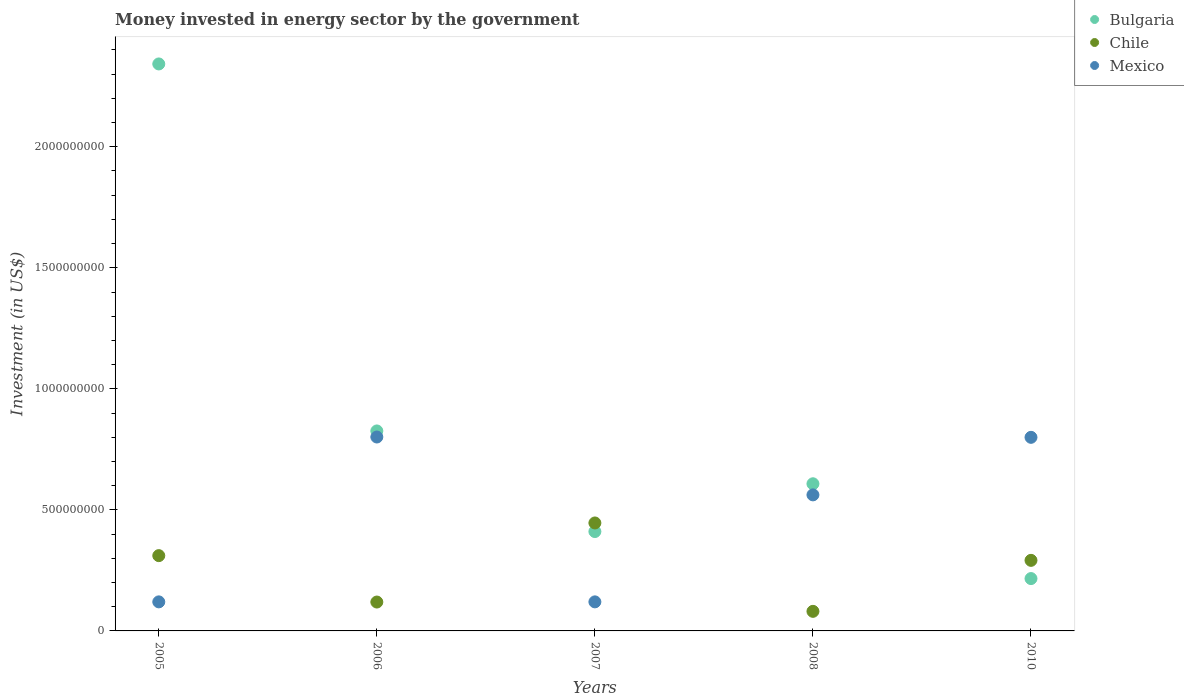Is the number of dotlines equal to the number of legend labels?
Provide a succinct answer. Yes. What is the money spent in energy sector in Mexico in 2005?
Your answer should be very brief. 1.20e+08. Across all years, what is the maximum money spent in energy sector in Bulgaria?
Offer a very short reply. 2.34e+09. Across all years, what is the minimum money spent in energy sector in Mexico?
Give a very brief answer. 1.20e+08. In which year was the money spent in energy sector in Bulgaria maximum?
Offer a very short reply. 2005. What is the total money spent in energy sector in Mexico in the graph?
Offer a very short reply. 2.40e+09. What is the difference between the money spent in energy sector in Mexico in 2005 and that in 2010?
Keep it short and to the point. -6.80e+08. What is the difference between the money spent in energy sector in Mexico in 2005 and the money spent in energy sector in Chile in 2008?
Provide a short and direct response. 3.91e+07. What is the average money spent in energy sector in Mexico per year?
Give a very brief answer. 4.81e+08. In the year 2007, what is the difference between the money spent in energy sector in Chile and money spent in energy sector in Bulgaria?
Ensure brevity in your answer.  3.55e+07. In how many years, is the money spent in energy sector in Chile greater than 1900000000 US$?
Give a very brief answer. 0. What is the ratio of the money spent in energy sector in Mexico in 2006 to that in 2007?
Provide a succinct answer. 6.67. Is the money spent in energy sector in Bulgaria in 2006 less than that in 2008?
Make the answer very short. No. What is the difference between the highest and the second highest money spent in energy sector in Bulgaria?
Provide a short and direct response. 1.52e+09. What is the difference between the highest and the lowest money spent in energy sector in Bulgaria?
Your response must be concise. 2.13e+09. Does the money spent in energy sector in Mexico monotonically increase over the years?
Make the answer very short. No. How many years are there in the graph?
Make the answer very short. 5. Does the graph contain any zero values?
Provide a short and direct response. No. Does the graph contain grids?
Make the answer very short. No. Where does the legend appear in the graph?
Keep it short and to the point. Top right. How many legend labels are there?
Ensure brevity in your answer.  3. How are the legend labels stacked?
Your answer should be very brief. Vertical. What is the title of the graph?
Give a very brief answer. Money invested in energy sector by the government. Does "Guinea-Bissau" appear as one of the legend labels in the graph?
Provide a succinct answer. No. What is the label or title of the X-axis?
Give a very brief answer. Years. What is the label or title of the Y-axis?
Your response must be concise. Investment (in US$). What is the Investment (in US$) in Bulgaria in 2005?
Give a very brief answer. 2.34e+09. What is the Investment (in US$) of Chile in 2005?
Your answer should be compact. 3.11e+08. What is the Investment (in US$) in Mexico in 2005?
Ensure brevity in your answer.  1.20e+08. What is the Investment (in US$) in Bulgaria in 2006?
Your answer should be very brief. 8.26e+08. What is the Investment (in US$) in Chile in 2006?
Offer a very short reply. 1.19e+08. What is the Investment (in US$) in Mexico in 2006?
Provide a short and direct response. 8.01e+08. What is the Investment (in US$) in Bulgaria in 2007?
Ensure brevity in your answer.  4.10e+08. What is the Investment (in US$) in Chile in 2007?
Keep it short and to the point. 4.46e+08. What is the Investment (in US$) of Mexico in 2007?
Provide a succinct answer. 1.20e+08. What is the Investment (in US$) in Bulgaria in 2008?
Your answer should be compact. 6.08e+08. What is the Investment (in US$) of Chile in 2008?
Give a very brief answer. 8.09e+07. What is the Investment (in US$) of Mexico in 2008?
Your answer should be compact. 5.62e+08. What is the Investment (in US$) in Bulgaria in 2010?
Ensure brevity in your answer.  2.16e+08. What is the Investment (in US$) of Chile in 2010?
Your answer should be very brief. 2.92e+08. What is the Investment (in US$) of Mexico in 2010?
Keep it short and to the point. 8.00e+08. Across all years, what is the maximum Investment (in US$) of Bulgaria?
Give a very brief answer. 2.34e+09. Across all years, what is the maximum Investment (in US$) of Chile?
Keep it short and to the point. 4.46e+08. Across all years, what is the maximum Investment (in US$) of Mexico?
Ensure brevity in your answer.  8.01e+08. Across all years, what is the minimum Investment (in US$) of Bulgaria?
Keep it short and to the point. 2.16e+08. Across all years, what is the minimum Investment (in US$) in Chile?
Ensure brevity in your answer.  8.09e+07. Across all years, what is the minimum Investment (in US$) in Mexico?
Provide a short and direct response. 1.20e+08. What is the total Investment (in US$) in Bulgaria in the graph?
Ensure brevity in your answer.  4.40e+09. What is the total Investment (in US$) of Chile in the graph?
Keep it short and to the point. 1.25e+09. What is the total Investment (in US$) of Mexico in the graph?
Give a very brief answer. 2.40e+09. What is the difference between the Investment (in US$) of Bulgaria in 2005 and that in 2006?
Keep it short and to the point. 1.52e+09. What is the difference between the Investment (in US$) in Chile in 2005 and that in 2006?
Provide a succinct answer. 1.92e+08. What is the difference between the Investment (in US$) in Mexico in 2005 and that in 2006?
Keep it short and to the point. -6.81e+08. What is the difference between the Investment (in US$) of Bulgaria in 2005 and that in 2007?
Your response must be concise. 1.93e+09. What is the difference between the Investment (in US$) of Chile in 2005 and that in 2007?
Offer a terse response. -1.35e+08. What is the difference between the Investment (in US$) of Bulgaria in 2005 and that in 2008?
Give a very brief answer. 1.73e+09. What is the difference between the Investment (in US$) in Chile in 2005 and that in 2008?
Ensure brevity in your answer.  2.30e+08. What is the difference between the Investment (in US$) of Mexico in 2005 and that in 2008?
Offer a terse response. -4.42e+08. What is the difference between the Investment (in US$) in Bulgaria in 2005 and that in 2010?
Make the answer very short. 2.13e+09. What is the difference between the Investment (in US$) of Chile in 2005 and that in 2010?
Provide a short and direct response. 1.95e+07. What is the difference between the Investment (in US$) of Mexico in 2005 and that in 2010?
Give a very brief answer. -6.80e+08. What is the difference between the Investment (in US$) in Bulgaria in 2006 and that in 2007?
Offer a terse response. 4.16e+08. What is the difference between the Investment (in US$) in Chile in 2006 and that in 2007?
Make the answer very short. -3.27e+08. What is the difference between the Investment (in US$) in Mexico in 2006 and that in 2007?
Provide a short and direct response. 6.81e+08. What is the difference between the Investment (in US$) of Bulgaria in 2006 and that in 2008?
Your answer should be compact. 2.18e+08. What is the difference between the Investment (in US$) of Chile in 2006 and that in 2008?
Give a very brief answer. 3.84e+07. What is the difference between the Investment (in US$) in Mexico in 2006 and that in 2008?
Provide a short and direct response. 2.39e+08. What is the difference between the Investment (in US$) of Bulgaria in 2006 and that in 2010?
Provide a succinct answer. 6.10e+08. What is the difference between the Investment (in US$) in Chile in 2006 and that in 2010?
Make the answer very short. -1.72e+08. What is the difference between the Investment (in US$) in Mexico in 2006 and that in 2010?
Provide a short and direct response. 1.30e+06. What is the difference between the Investment (in US$) of Bulgaria in 2007 and that in 2008?
Your answer should be very brief. -1.97e+08. What is the difference between the Investment (in US$) of Chile in 2007 and that in 2008?
Offer a very short reply. 3.65e+08. What is the difference between the Investment (in US$) in Mexico in 2007 and that in 2008?
Provide a succinct answer. -4.42e+08. What is the difference between the Investment (in US$) in Bulgaria in 2007 and that in 2010?
Offer a terse response. 1.94e+08. What is the difference between the Investment (in US$) in Chile in 2007 and that in 2010?
Ensure brevity in your answer.  1.54e+08. What is the difference between the Investment (in US$) in Mexico in 2007 and that in 2010?
Your answer should be very brief. -6.80e+08. What is the difference between the Investment (in US$) of Bulgaria in 2008 and that in 2010?
Provide a short and direct response. 3.92e+08. What is the difference between the Investment (in US$) in Chile in 2008 and that in 2010?
Make the answer very short. -2.11e+08. What is the difference between the Investment (in US$) in Mexico in 2008 and that in 2010?
Give a very brief answer. -2.38e+08. What is the difference between the Investment (in US$) of Bulgaria in 2005 and the Investment (in US$) of Chile in 2006?
Provide a short and direct response. 2.22e+09. What is the difference between the Investment (in US$) of Bulgaria in 2005 and the Investment (in US$) of Mexico in 2006?
Give a very brief answer. 1.54e+09. What is the difference between the Investment (in US$) of Chile in 2005 and the Investment (in US$) of Mexico in 2006?
Offer a very short reply. -4.90e+08. What is the difference between the Investment (in US$) of Bulgaria in 2005 and the Investment (in US$) of Chile in 2007?
Ensure brevity in your answer.  1.90e+09. What is the difference between the Investment (in US$) of Bulgaria in 2005 and the Investment (in US$) of Mexico in 2007?
Keep it short and to the point. 2.22e+09. What is the difference between the Investment (in US$) of Chile in 2005 and the Investment (in US$) of Mexico in 2007?
Your answer should be compact. 1.91e+08. What is the difference between the Investment (in US$) of Bulgaria in 2005 and the Investment (in US$) of Chile in 2008?
Make the answer very short. 2.26e+09. What is the difference between the Investment (in US$) in Bulgaria in 2005 and the Investment (in US$) in Mexico in 2008?
Make the answer very short. 1.78e+09. What is the difference between the Investment (in US$) in Chile in 2005 and the Investment (in US$) in Mexico in 2008?
Keep it short and to the point. -2.51e+08. What is the difference between the Investment (in US$) of Bulgaria in 2005 and the Investment (in US$) of Chile in 2010?
Give a very brief answer. 2.05e+09. What is the difference between the Investment (in US$) of Bulgaria in 2005 and the Investment (in US$) of Mexico in 2010?
Keep it short and to the point. 1.54e+09. What is the difference between the Investment (in US$) in Chile in 2005 and the Investment (in US$) in Mexico in 2010?
Your answer should be very brief. -4.89e+08. What is the difference between the Investment (in US$) in Bulgaria in 2006 and the Investment (in US$) in Chile in 2007?
Offer a very short reply. 3.80e+08. What is the difference between the Investment (in US$) of Bulgaria in 2006 and the Investment (in US$) of Mexico in 2007?
Your answer should be compact. 7.06e+08. What is the difference between the Investment (in US$) in Chile in 2006 and the Investment (in US$) in Mexico in 2007?
Ensure brevity in your answer.  -7.00e+05. What is the difference between the Investment (in US$) in Bulgaria in 2006 and the Investment (in US$) in Chile in 2008?
Provide a short and direct response. 7.45e+08. What is the difference between the Investment (in US$) in Bulgaria in 2006 and the Investment (in US$) in Mexico in 2008?
Your answer should be very brief. 2.64e+08. What is the difference between the Investment (in US$) of Chile in 2006 and the Investment (in US$) of Mexico in 2008?
Offer a very short reply. -4.43e+08. What is the difference between the Investment (in US$) of Bulgaria in 2006 and the Investment (in US$) of Chile in 2010?
Offer a very short reply. 5.35e+08. What is the difference between the Investment (in US$) of Bulgaria in 2006 and the Investment (in US$) of Mexico in 2010?
Keep it short and to the point. 2.64e+07. What is the difference between the Investment (in US$) of Chile in 2006 and the Investment (in US$) of Mexico in 2010?
Offer a very short reply. -6.80e+08. What is the difference between the Investment (in US$) in Bulgaria in 2007 and the Investment (in US$) in Chile in 2008?
Provide a short and direct response. 3.30e+08. What is the difference between the Investment (in US$) in Bulgaria in 2007 and the Investment (in US$) in Mexico in 2008?
Ensure brevity in your answer.  -1.52e+08. What is the difference between the Investment (in US$) of Chile in 2007 and the Investment (in US$) of Mexico in 2008?
Offer a very short reply. -1.16e+08. What is the difference between the Investment (in US$) in Bulgaria in 2007 and the Investment (in US$) in Chile in 2010?
Provide a succinct answer. 1.19e+08. What is the difference between the Investment (in US$) in Bulgaria in 2007 and the Investment (in US$) in Mexico in 2010?
Keep it short and to the point. -3.89e+08. What is the difference between the Investment (in US$) in Chile in 2007 and the Investment (in US$) in Mexico in 2010?
Provide a succinct answer. -3.54e+08. What is the difference between the Investment (in US$) of Bulgaria in 2008 and the Investment (in US$) of Chile in 2010?
Offer a terse response. 3.16e+08. What is the difference between the Investment (in US$) in Bulgaria in 2008 and the Investment (in US$) in Mexico in 2010?
Keep it short and to the point. -1.92e+08. What is the difference between the Investment (in US$) of Chile in 2008 and the Investment (in US$) of Mexico in 2010?
Ensure brevity in your answer.  -7.19e+08. What is the average Investment (in US$) in Bulgaria per year?
Provide a short and direct response. 8.81e+08. What is the average Investment (in US$) of Chile per year?
Make the answer very short. 2.50e+08. What is the average Investment (in US$) of Mexico per year?
Provide a succinct answer. 4.81e+08. In the year 2005, what is the difference between the Investment (in US$) in Bulgaria and Investment (in US$) in Chile?
Offer a terse response. 2.03e+09. In the year 2005, what is the difference between the Investment (in US$) in Bulgaria and Investment (in US$) in Mexico?
Provide a succinct answer. 2.22e+09. In the year 2005, what is the difference between the Investment (in US$) of Chile and Investment (in US$) of Mexico?
Provide a succinct answer. 1.91e+08. In the year 2006, what is the difference between the Investment (in US$) of Bulgaria and Investment (in US$) of Chile?
Your answer should be very brief. 7.07e+08. In the year 2006, what is the difference between the Investment (in US$) in Bulgaria and Investment (in US$) in Mexico?
Offer a very short reply. 2.51e+07. In the year 2006, what is the difference between the Investment (in US$) in Chile and Investment (in US$) in Mexico?
Your response must be concise. -6.82e+08. In the year 2007, what is the difference between the Investment (in US$) in Bulgaria and Investment (in US$) in Chile?
Keep it short and to the point. -3.55e+07. In the year 2007, what is the difference between the Investment (in US$) of Bulgaria and Investment (in US$) of Mexico?
Make the answer very short. 2.90e+08. In the year 2007, what is the difference between the Investment (in US$) of Chile and Investment (in US$) of Mexico?
Offer a terse response. 3.26e+08. In the year 2008, what is the difference between the Investment (in US$) in Bulgaria and Investment (in US$) in Chile?
Provide a succinct answer. 5.27e+08. In the year 2008, what is the difference between the Investment (in US$) in Bulgaria and Investment (in US$) in Mexico?
Ensure brevity in your answer.  4.59e+07. In the year 2008, what is the difference between the Investment (in US$) in Chile and Investment (in US$) in Mexico?
Your answer should be very brief. -4.81e+08. In the year 2010, what is the difference between the Investment (in US$) in Bulgaria and Investment (in US$) in Chile?
Your answer should be compact. -7.53e+07. In the year 2010, what is the difference between the Investment (in US$) of Bulgaria and Investment (in US$) of Mexico?
Offer a terse response. -5.83e+08. In the year 2010, what is the difference between the Investment (in US$) in Chile and Investment (in US$) in Mexico?
Your response must be concise. -5.08e+08. What is the ratio of the Investment (in US$) of Bulgaria in 2005 to that in 2006?
Your response must be concise. 2.84. What is the ratio of the Investment (in US$) of Chile in 2005 to that in 2006?
Give a very brief answer. 2.61. What is the ratio of the Investment (in US$) of Mexico in 2005 to that in 2006?
Keep it short and to the point. 0.15. What is the ratio of the Investment (in US$) in Bulgaria in 2005 to that in 2007?
Ensure brevity in your answer.  5.71. What is the ratio of the Investment (in US$) in Chile in 2005 to that in 2007?
Offer a very short reply. 0.7. What is the ratio of the Investment (in US$) of Bulgaria in 2005 to that in 2008?
Offer a very short reply. 3.85. What is the ratio of the Investment (in US$) of Chile in 2005 to that in 2008?
Your answer should be compact. 3.85. What is the ratio of the Investment (in US$) of Mexico in 2005 to that in 2008?
Your answer should be compact. 0.21. What is the ratio of the Investment (in US$) of Bulgaria in 2005 to that in 2010?
Give a very brief answer. 10.83. What is the ratio of the Investment (in US$) in Chile in 2005 to that in 2010?
Your answer should be very brief. 1.07. What is the ratio of the Investment (in US$) of Mexico in 2005 to that in 2010?
Offer a terse response. 0.15. What is the ratio of the Investment (in US$) in Bulgaria in 2006 to that in 2007?
Provide a succinct answer. 2.01. What is the ratio of the Investment (in US$) of Chile in 2006 to that in 2007?
Provide a short and direct response. 0.27. What is the ratio of the Investment (in US$) in Mexico in 2006 to that in 2007?
Give a very brief answer. 6.67. What is the ratio of the Investment (in US$) in Bulgaria in 2006 to that in 2008?
Provide a succinct answer. 1.36. What is the ratio of the Investment (in US$) in Chile in 2006 to that in 2008?
Your response must be concise. 1.48. What is the ratio of the Investment (in US$) in Mexico in 2006 to that in 2008?
Ensure brevity in your answer.  1.43. What is the ratio of the Investment (in US$) of Bulgaria in 2006 to that in 2010?
Give a very brief answer. 3.82. What is the ratio of the Investment (in US$) in Chile in 2006 to that in 2010?
Make the answer very short. 0.41. What is the ratio of the Investment (in US$) in Mexico in 2006 to that in 2010?
Ensure brevity in your answer.  1. What is the ratio of the Investment (in US$) in Bulgaria in 2007 to that in 2008?
Your answer should be very brief. 0.68. What is the ratio of the Investment (in US$) of Chile in 2007 to that in 2008?
Provide a succinct answer. 5.51. What is the ratio of the Investment (in US$) of Mexico in 2007 to that in 2008?
Make the answer very short. 0.21. What is the ratio of the Investment (in US$) in Bulgaria in 2007 to that in 2010?
Your answer should be very brief. 1.9. What is the ratio of the Investment (in US$) in Chile in 2007 to that in 2010?
Offer a very short reply. 1.53. What is the ratio of the Investment (in US$) of Mexico in 2007 to that in 2010?
Offer a terse response. 0.15. What is the ratio of the Investment (in US$) of Bulgaria in 2008 to that in 2010?
Provide a short and direct response. 2.81. What is the ratio of the Investment (in US$) of Chile in 2008 to that in 2010?
Provide a succinct answer. 0.28. What is the ratio of the Investment (in US$) of Mexico in 2008 to that in 2010?
Provide a short and direct response. 0.7. What is the difference between the highest and the second highest Investment (in US$) in Bulgaria?
Provide a succinct answer. 1.52e+09. What is the difference between the highest and the second highest Investment (in US$) in Chile?
Ensure brevity in your answer.  1.35e+08. What is the difference between the highest and the second highest Investment (in US$) of Mexico?
Provide a short and direct response. 1.30e+06. What is the difference between the highest and the lowest Investment (in US$) in Bulgaria?
Make the answer very short. 2.13e+09. What is the difference between the highest and the lowest Investment (in US$) of Chile?
Provide a short and direct response. 3.65e+08. What is the difference between the highest and the lowest Investment (in US$) in Mexico?
Offer a very short reply. 6.81e+08. 